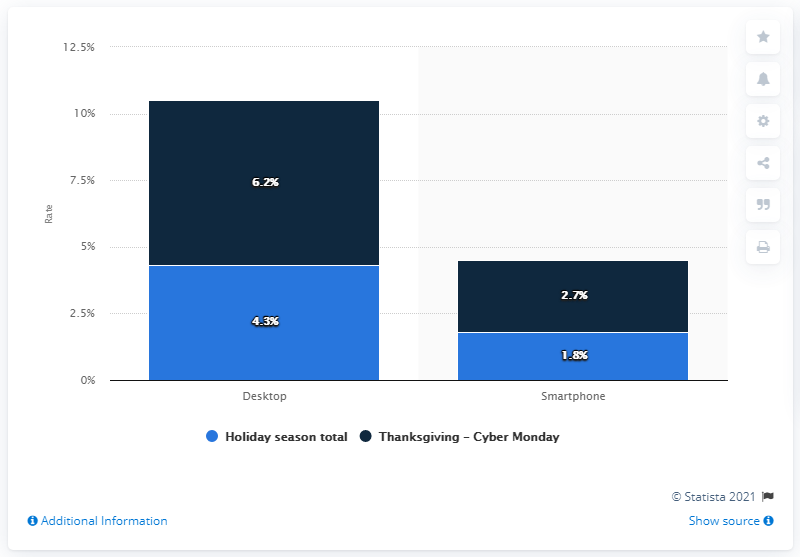Draw attention to some important aspects in this diagram. During the Thanksgiving to Cyber Monday weekend, the smartphone shopping conversion rate was 2.7%. 